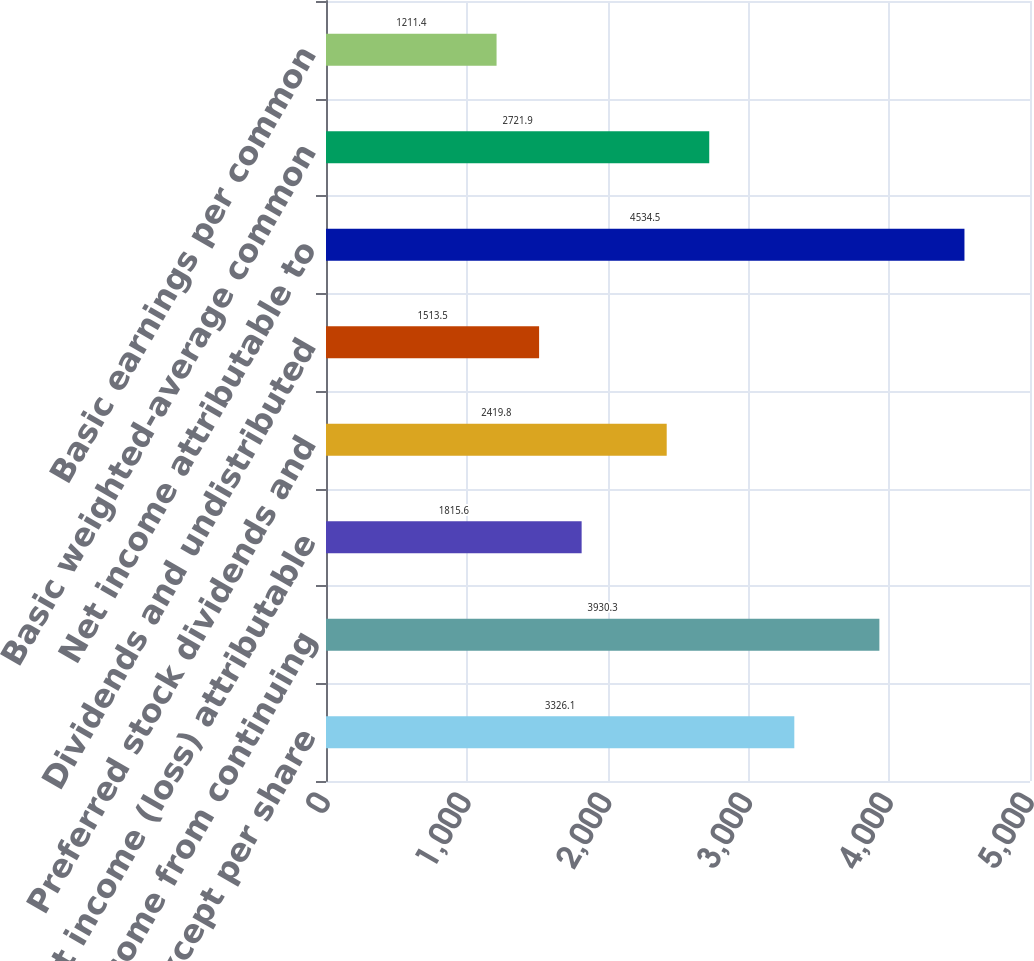Convert chart. <chart><loc_0><loc_0><loc_500><loc_500><bar_chart><fcel>In millions except per share<fcel>Net income from continuing<fcel>Net income (loss) attributable<fcel>Preferred stock dividends and<fcel>Dividends and undistributed<fcel>Net income attributable to<fcel>Basic weighted-average common<fcel>Basic earnings per common<nl><fcel>3326.1<fcel>3930.3<fcel>1815.6<fcel>2419.8<fcel>1513.5<fcel>4534.5<fcel>2721.9<fcel>1211.4<nl></chart> 